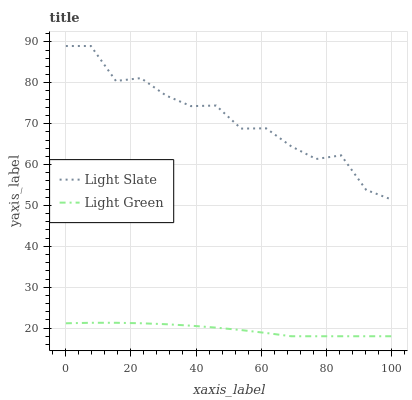Does Light Green have the minimum area under the curve?
Answer yes or no. Yes. Does Light Slate have the maximum area under the curve?
Answer yes or no. Yes. Does Light Green have the maximum area under the curve?
Answer yes or no. No. Is Light Green the smoothest?
Answer yes or no. Yes. Is Light Slate the roughest?
Answer yes or no. Yes. Is Light Green the roughest?
Answer yes or no. No. Does Light Green have the lowest value?
Answer yes or no. Yes. Does Light Slate have the highest value?
Answer yes or no. Yes. Does Light Green have the highest value?
Answer yes or no. No. Is Light Green less than Light Slate?
Answer yes or no. Yes. Is Light Slate greater than Light Green?
Answer yes or no. Yes. Does Light Green intersect Light Slate?
Answer yes or no. No. 